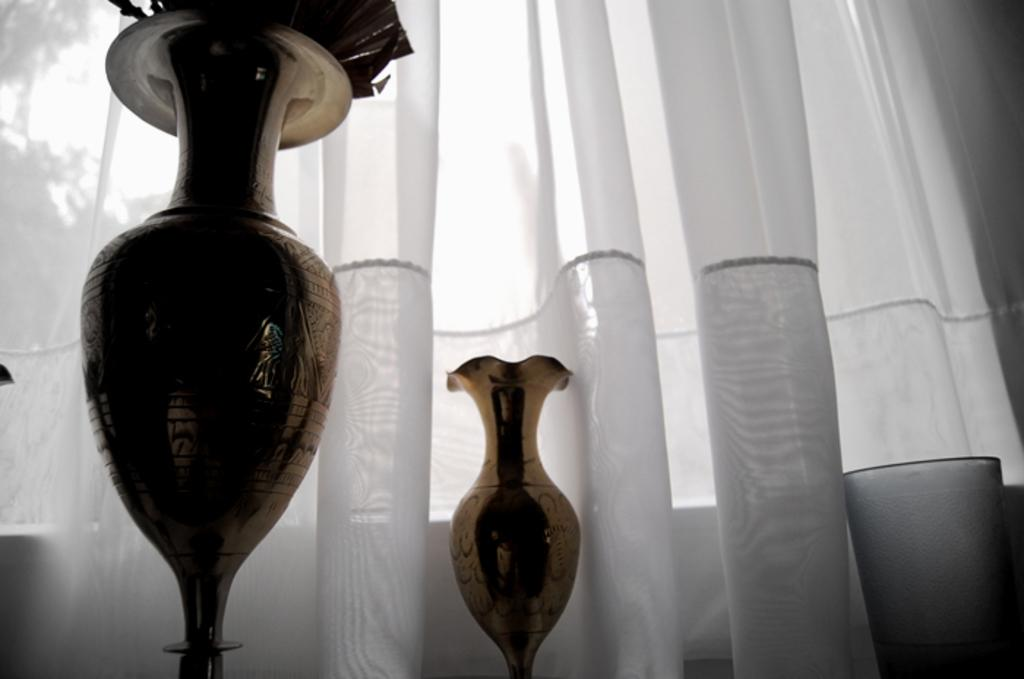What type of objects can be seen in the image? There are flower pots in the image. Can you describe any other elements in the image? There is a white color curtain in the image. Where is the sofa located in the image? There is no sofa present in the image. What is the point of the flower pots in the image? The flower pots in the image serve a decorative purpose and may also hold plants. 